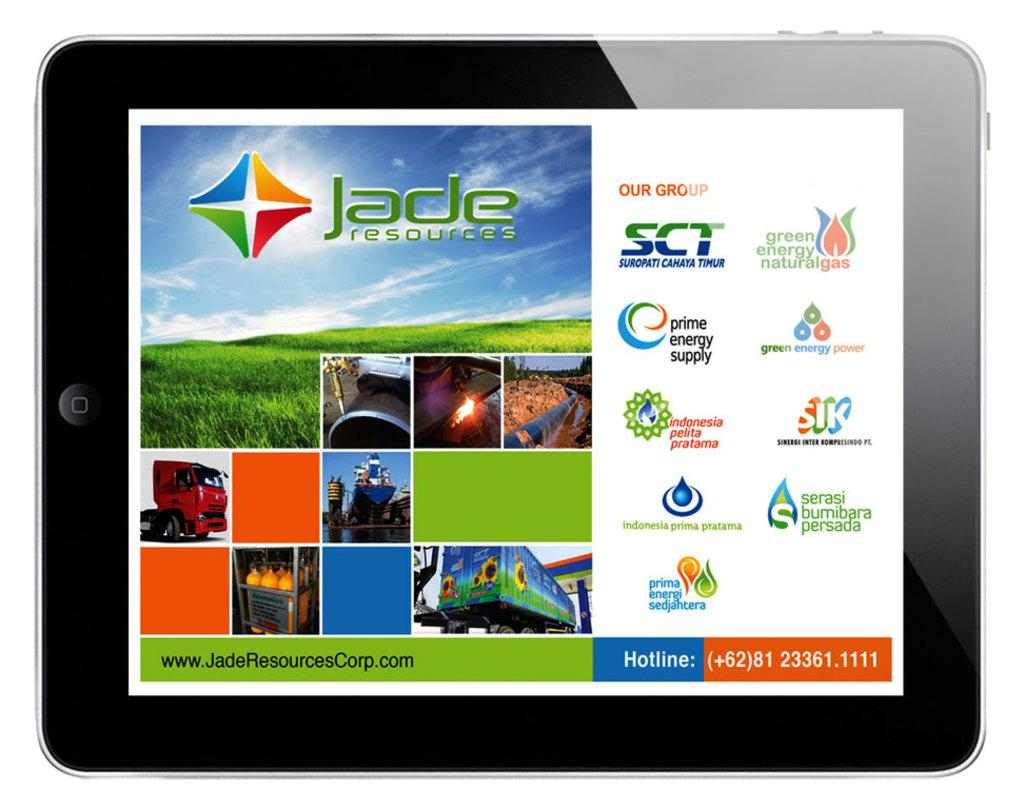What electronic device is visible in the image? There is an iPad in the image. What is displayed on the iPad's screen? The iPad has company names and pictures displayed on it. What type of part is the beggar looking for in the image? There is no beggar present in the image, and therefore no such activity can be observed. 